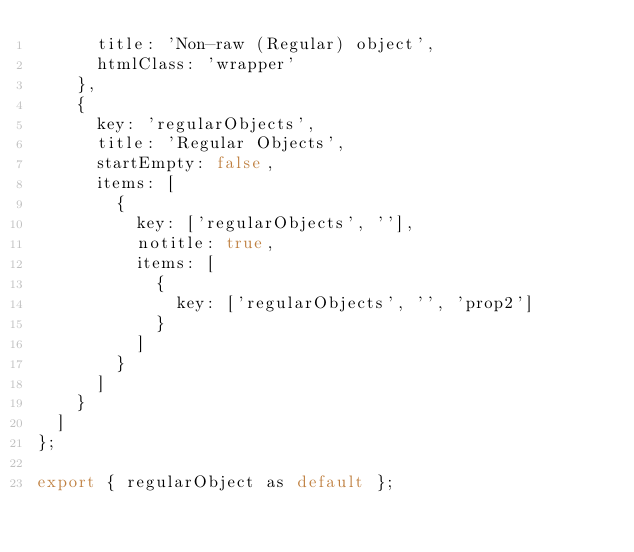Convert code to text. <code><loc_0><loc_0><loc_500><loc_500><_JavaScript_>      title: 'Non-raw (Regular) object',
      htmlClass: 'wrapper'
    },
    {
      key: 'regularObjects',
      title: 'Regular Objects',
      startEmpty: false,
      items: [
        {
          key: ['regularObjects', ''],
          notitle: true,
          items: [
            {
              key: ['regularObjects', '', 'prop2']
            }
          ]
        }
      ]
    }
  ]
};

export { regularObject as default };
</code> 